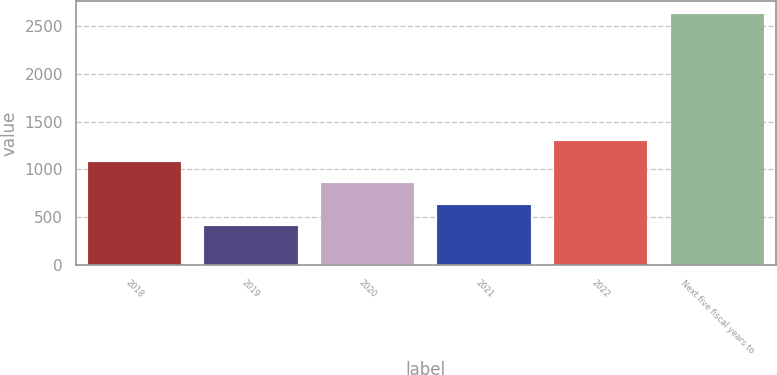Convert chart to OTSL. <chart><loc_0><loc_0><loc_500><loc_500><bar_chart><fcel>2018<fcel>2019<fcel>2020<fcel>2021<fcel>2022<fcel>Next five fiscal years to<nl><fcel>1075.1<fcel>410<fcel>853.4<fcel>631.7<fcel>1296.8<fcel>2627<nl></chart> 